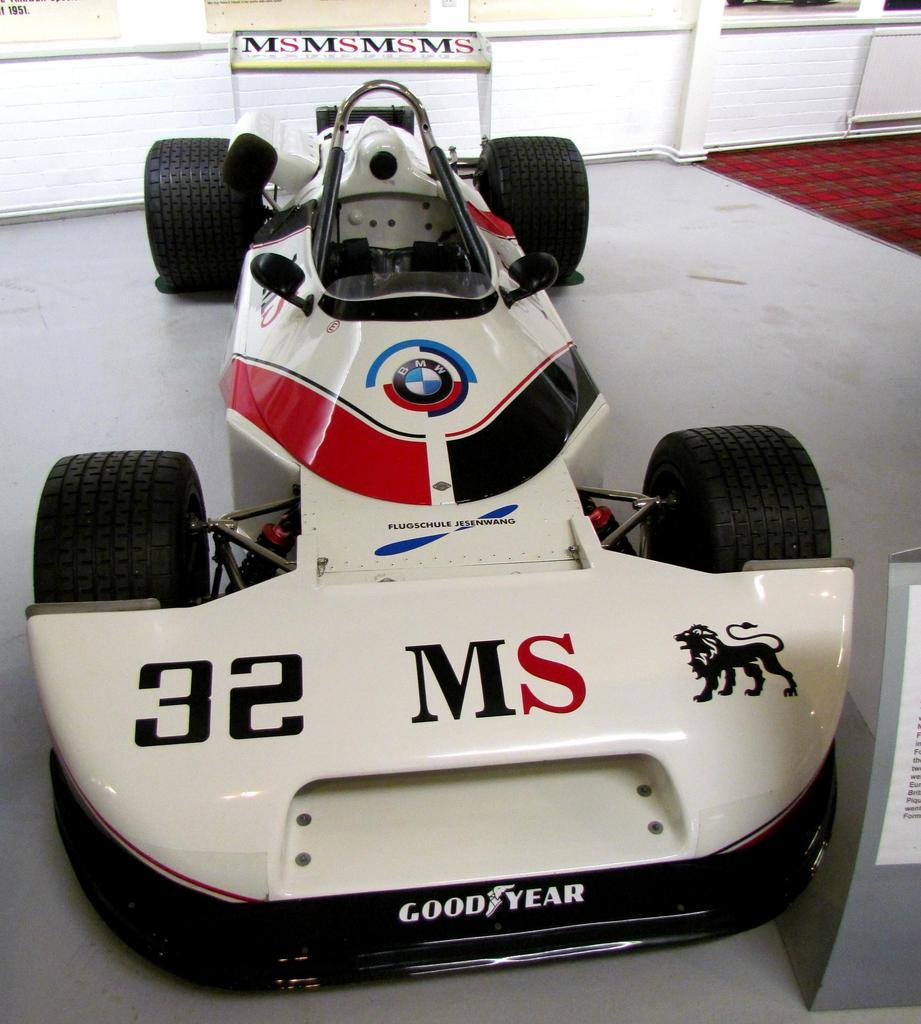What is the main subject of the image? The main subject of the image is a car on the road. Can you describe the object in front of the car? There is an object in front of the car, but its specific details are not mentioned in the facts. What can be seen in the background of the image? In the background of the image, there is a wall with posters on it. What type of punishment is being given to the bread in the image? There is no bread present in the image, so it cannot be given any punishment. 